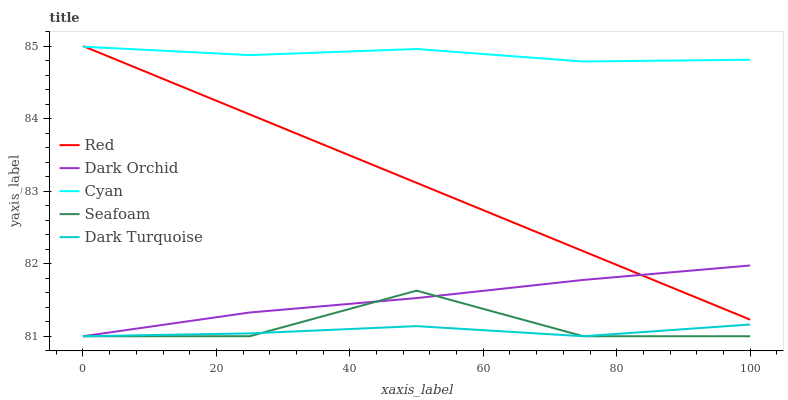Does Dark Turquoise have the minimum area under the curve?
Answer yes or no. Yes. Does Cyan have the maximum area under the curve?
Answer yes or no. Yes. Does Dark Orchid have the minimum area under the curve?
Answer yes or no. No. Does Dark Orchid have the maximum area under the curve?
Answer yes or no. No. Is Red the smoothest?
Answer yes or no. Yes. Is Seafoam the roughest?
Answer yes or no. Yes. Is Dark Turquoise the smoothest?
Answer yes or no. No. Is Dark Turquoise the roughest?
Answer yes or no. No. Does Dark Turquoise have the lowest value?
Answer yes or no. Yes. Does Red have the lowest value?
Answer yes or no. No. Does Red have the highest value?
Answer yes or no. Yes. Does Dark Orchid have the highest value?
Answer yes or no. No. Is Seafoam less than Red?
Answer yes or no. Yes. Is Red greater than Dark Turquoise?
Answer yes or no. Yes. Does Seafoam intersect Dark Orchid?
Answer yes or no. Yes. Is Seafoam less than Dark Orchid?
Answer yes or no. No. Is Seafoam greater than Dark Orchid?
Answer yes or no. No. Does Seafoam intersect Red?
Answer yes or no. No. 